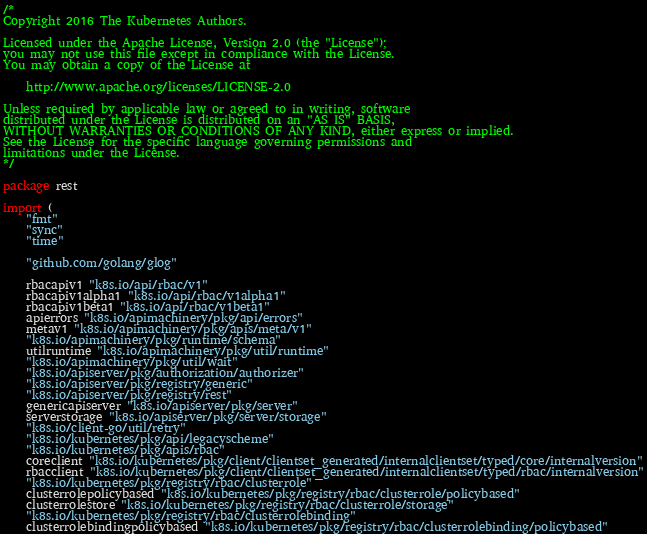<code> <loc_0><loc_0><loc_500><loc_500><_Go_>/*
Copyright 2016 The Kubernetes Authors.

Licensed under the Apache License, Version 2.0 (the "License");
you may not use this file except in compliance with the License.
You may obtain a copy of the License at

    http://www.apache.org/licenses/LICENSE-2.0

Unless required by applicable law or agreed to in writing, software
distributed under the License is distributed on an "AS IS" BASIS,
WITHOUT WARRANTIES OR CONDITIONS OF ANY KIND, either express or implied.
See the License for the specific language governing permissions and
limitations under the License.
*/

package rest

import (
	"fmt"
	"sync"
	"time"

	"github.com/golang/glog"

	rbacapiv1 "k8s.io/api/rbac/v1"
	rbacapiv1alpha1 "k8s.io/api/rbac/v1alpha1"
	rbacapiv1beta1 "k8s.io/api/rbac/v1beta1"
	apierrors "k8s.io/apimachinery/pkg/api/errors"
	metav1 "k8s.io/apimachinery/pkg/apis/meta/v1"
	"k8s.io/apimachinery/pkg/runtime/schema"
	utilruntime "k8s.io/apimachinery/pkg/util/runtime"
	"k8s.io/apimachinery/pkg/util/wait"
	"k8s.io/apiserver/pkg/authorization/authorizer"
	"k8s.io/apiserver/pkg/registry/generic"
	"k8s.io/apiserver/pkg/registry/rest"
	genericapiserver "k8s.io/apiserver/pkg/server"
	serverstorage "k8s.io/apiserver/pkg/server/storage"
	"k8s.io/client-go/util/retry"
	"k8s.io/kubernetes/pkg/api/legacyscheme"
	"k8s.io/kubernetes/pkg/apis/rbac"
	coreclient "k8s.io/kubernetes/pkg/client/clientset_generated/internalclientset/typed/core/internalversion"
	rbacclient "k8s.io/kubernetes/pkg/client/clientset_generated/internalclientset/typed/rbac/internalversion"
	"k8s.io/kubernetes/pkg/registry/rbac/clusterrole"
	clusterrolepolicybased "k8s.io/kubernetes/pkg/registry/rbac/clusterrole/policybased"
	clusterrolestore "k8s.io/kubernetes/pkg/registry/rbac/clusterrole/storage"
	"k8s.io/kubernetes/pkg/registry/rbac/clusterrolebinding"
	clusterrolebindingpolicybased "k8s.io/kubernetes/pkg/registry/rbac/clusterrolebinding/policybased"</code> 